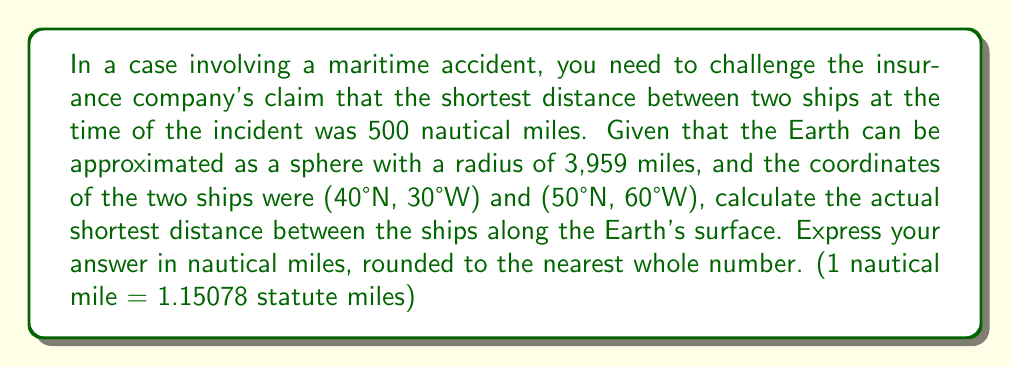Solve this math problem. To solve this problem, we need to use the great circle distance formula on a spherical surface. Here's the step-by-step solution:

1) Convert the latitude and longitude to radians:
   $\phi_1 = 40° \cdot \frac{\pi}{180} = 0.6981$ rad
   $\lambda_1 = -30° \cdot \frac{\pi}{180} = -0.5236$ rad
   $\phi_2 = 50° \cdot \frac{\pi}{180} = 0.8727$ rad
   $\lambda_2 = -60° \cdot \frac{\pi}{180} = -1.0472$ rad

2) Use the Haversine formula to calculate the central angle $\theta$:
   $$\theta = 2 \arcsin\left(\sqrt{\sin^2\left(\frac{\phi_2-\phi_1}{2}\right) + \cos(\phi_1)\cos(\phi_2)\sin^2\left(\frac{\lambda_2-\lambda_1}{2}\right)}\right)$$

3) Substitute the values:
   $$\theta = 2 \arcsin\left(\sqrt{\sin^2\left(\frac{0.8727-0.6981}{2}\right) + \cos(0.6981)\cos(0.8727)\sin^2\left(\frac{-1.0472-(-0.5236)}{2}\right)}\right)$$

4) Calculate:
   $\theta \approx 0.5704$ radians

5) The distance $d$ along the great circle is:
   $d = R \cdot \theta$
   where $R$ is the Earth's radius (3,959 miles)

   $d = 3959 \cdot 0.5704 \approx 2258.3148$ statute miles

6) Convert to nautical miles:
   $2258.3148 / 1.15078 \approx 1962.4$ nautical miles

7) Round to the nearest whole number:
   1962 nautical miles
Answer: 1962 nautical miles 